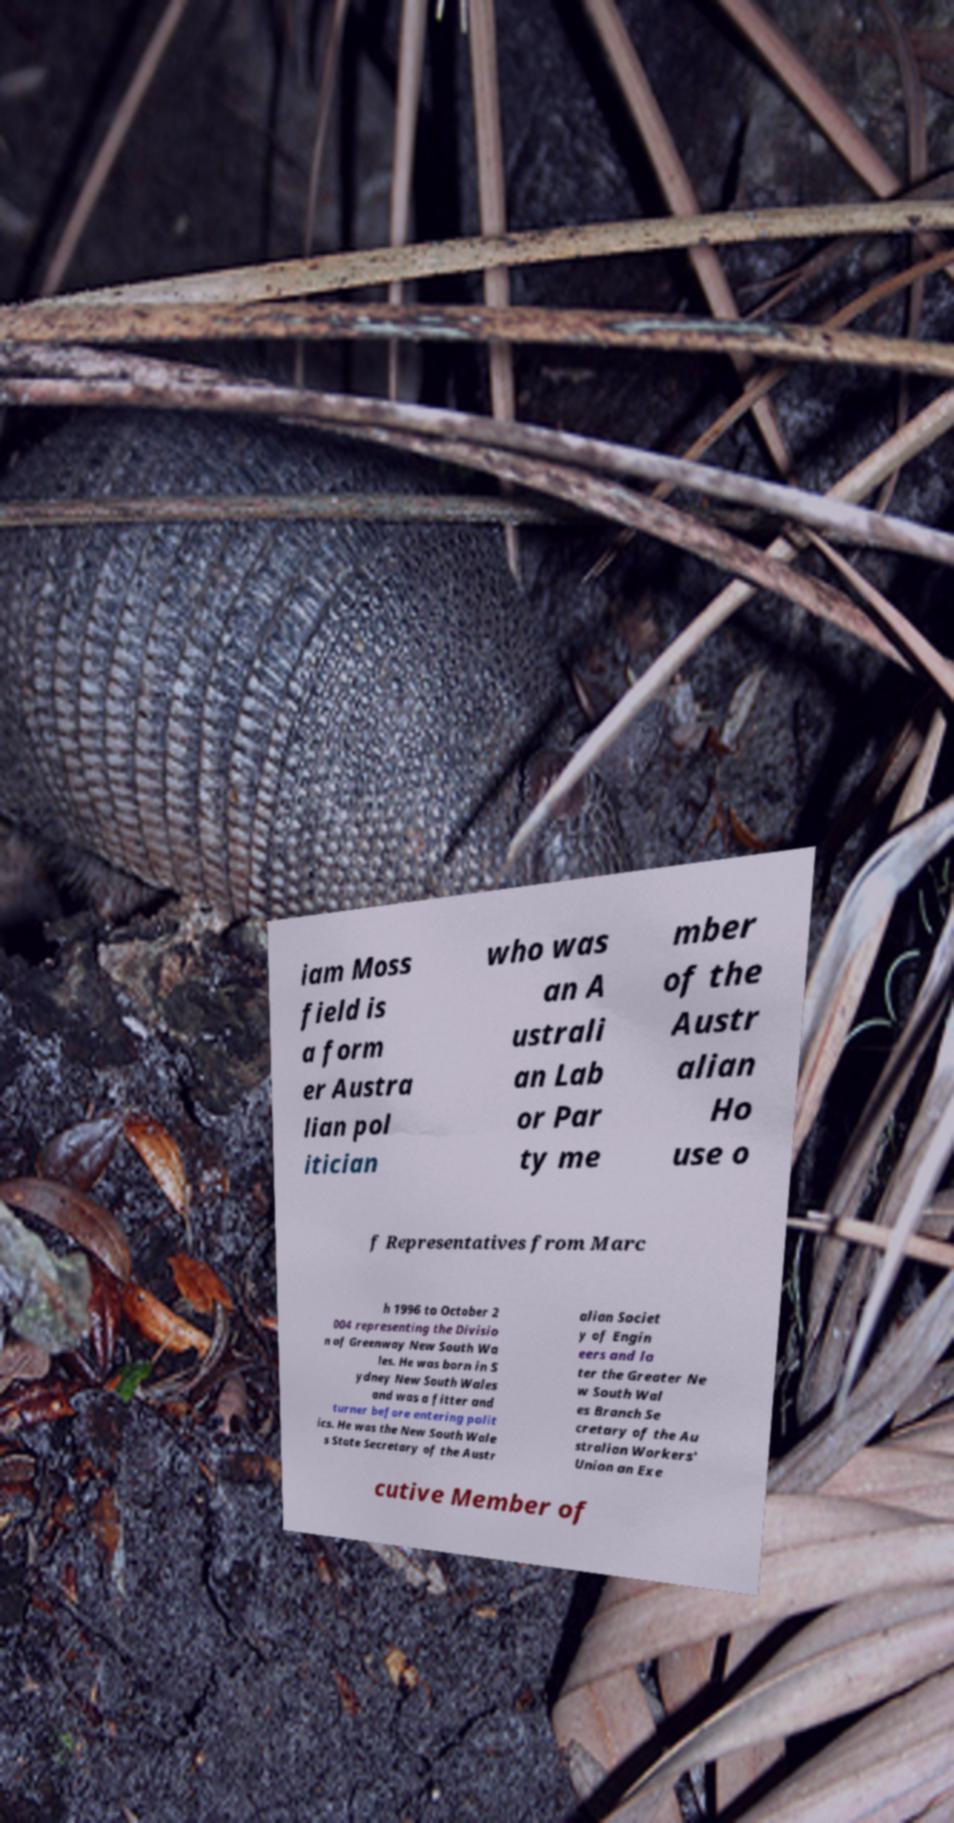Could you assist in decoding the text presented in this image and type it out clearly? iam Moss field is a form er Austra lian pol itician who was an A ustrali an Lab or Par ty me mber of the Austr alian Ho use o f Representatives from Marc h 1996 to October 2 004 representing the Divisio n of Greenway New South Wa les. He was born in S ydney New South Wales and was a fitter and turner before entering polit ics. He was the New South Wale s State Secretary of the Austr alian Societ y of Engin eers and la ter the Greater Ne w South Wal es Branch Se cretary of the Au stralian Workers' Union an Exe cutive Member of 